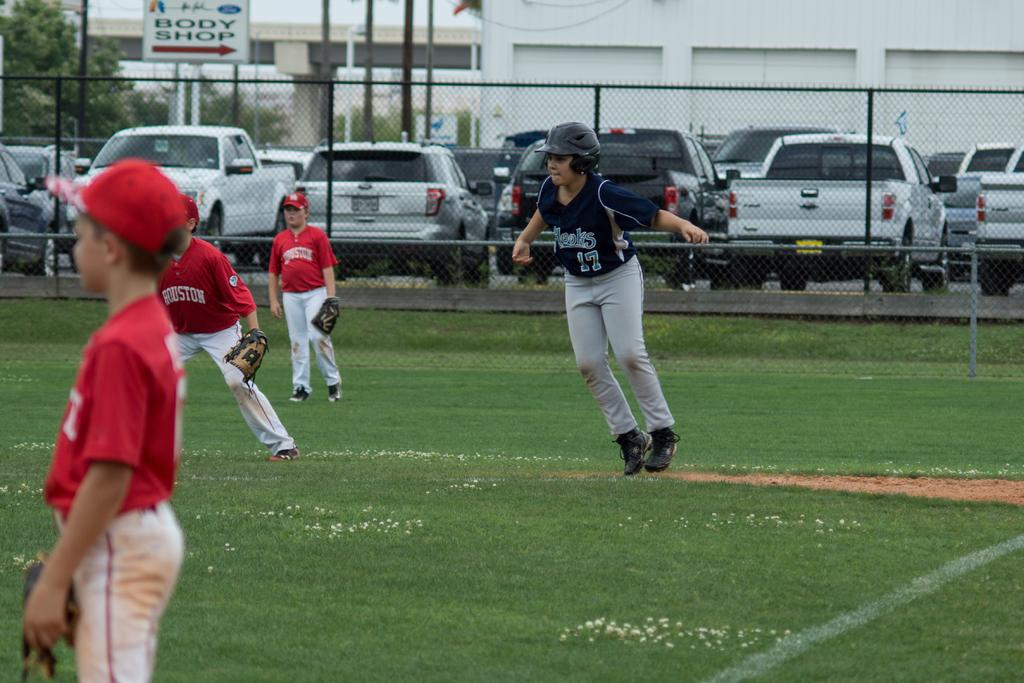<image>
Describe the image concisely. Players in red baseball jerseys saying Houston on defense with a runner on first base. 